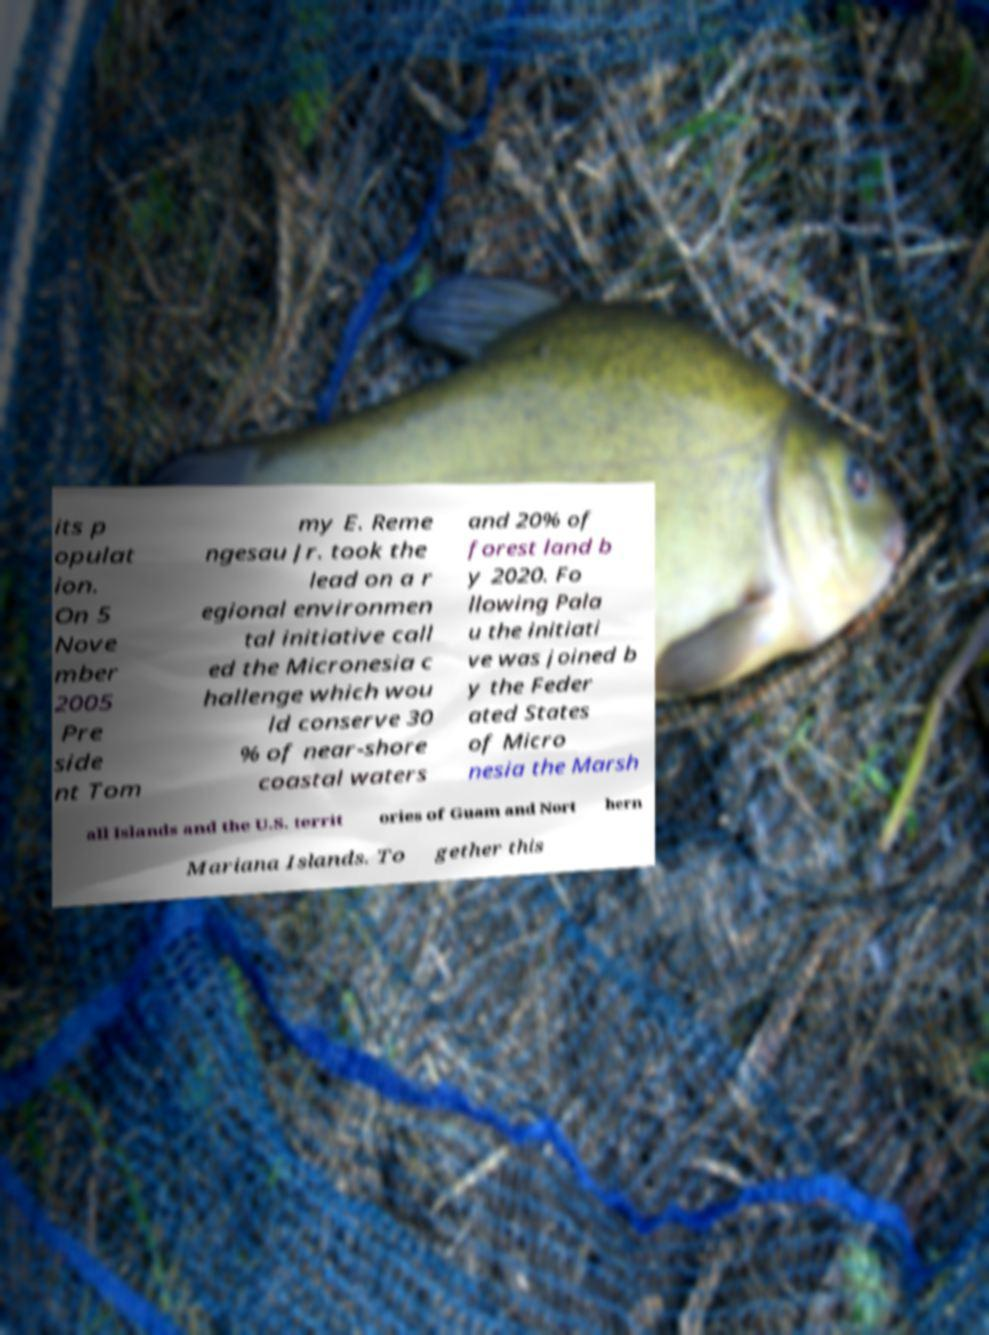For documentation purposes, I need the text within this image transcribed. Could you provide that? its p opulat ion. On 5 Nove mber 2005 Pre side nt Tom my E. Reme ngesau Jr. took the lead on a r egional environmen tal initiative call ed the Micronesia c hallenge which wou ld conserve 30 % of near-shore coastal waters and 20% of forest land b y 2020. Fo llowing Pala u the initiati ve was joined b y the Feder ated States of Micro nesia the Marsh all Islands and the U.S. territ ories of Guam and Nort hern Mariana Islands. To gether this 